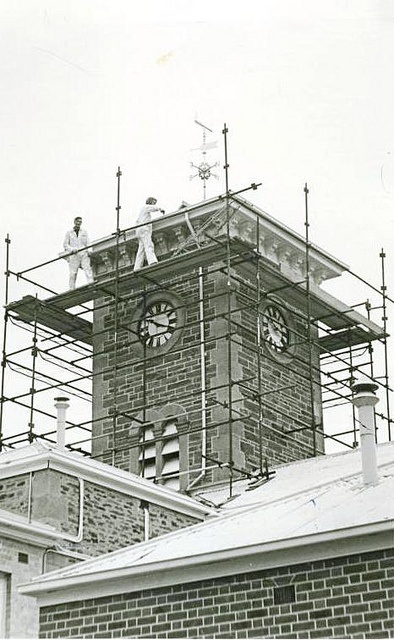Describe the objects in this image and their specific colors. I can see clock in white, gray, black, darkgray, and lightgray tones, clock in white, black, darkgray, gray, and lightgray tones, people in white, lightgray, darkgray, and gray tones, and people in white, lightgray, darkgray, gray, and black tones in this image. 